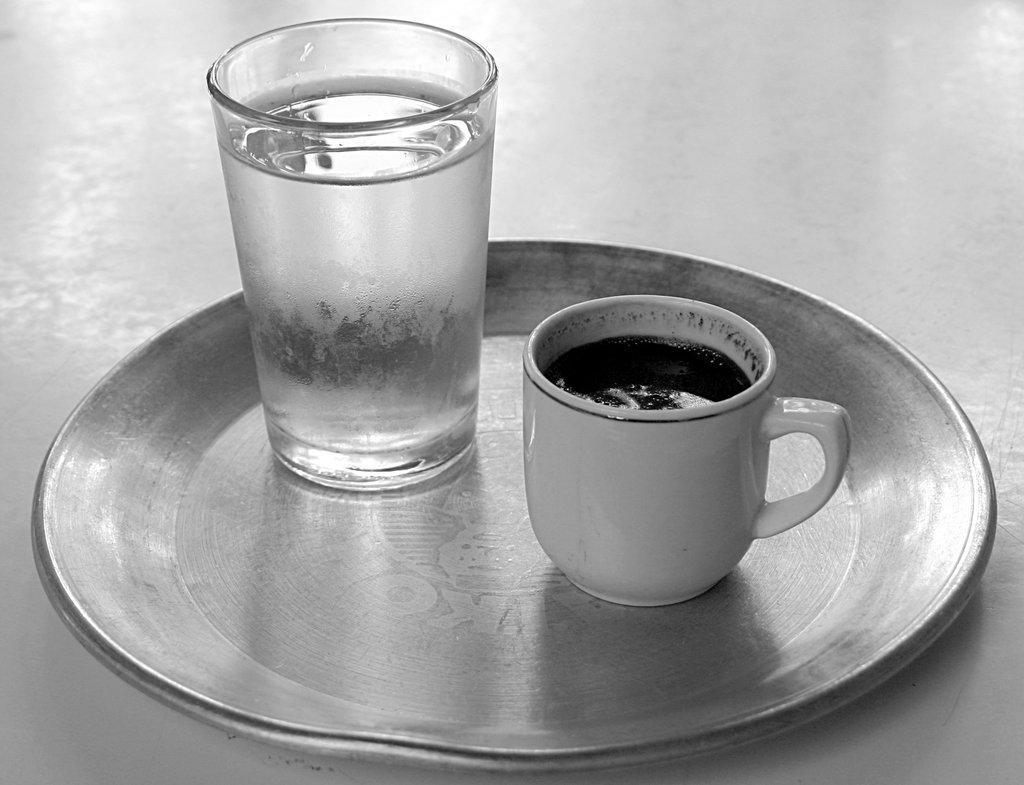How would you summarize this image in a sentence or two? In this picture I can see a glass and a cup on the table and looks like a table in the background. 